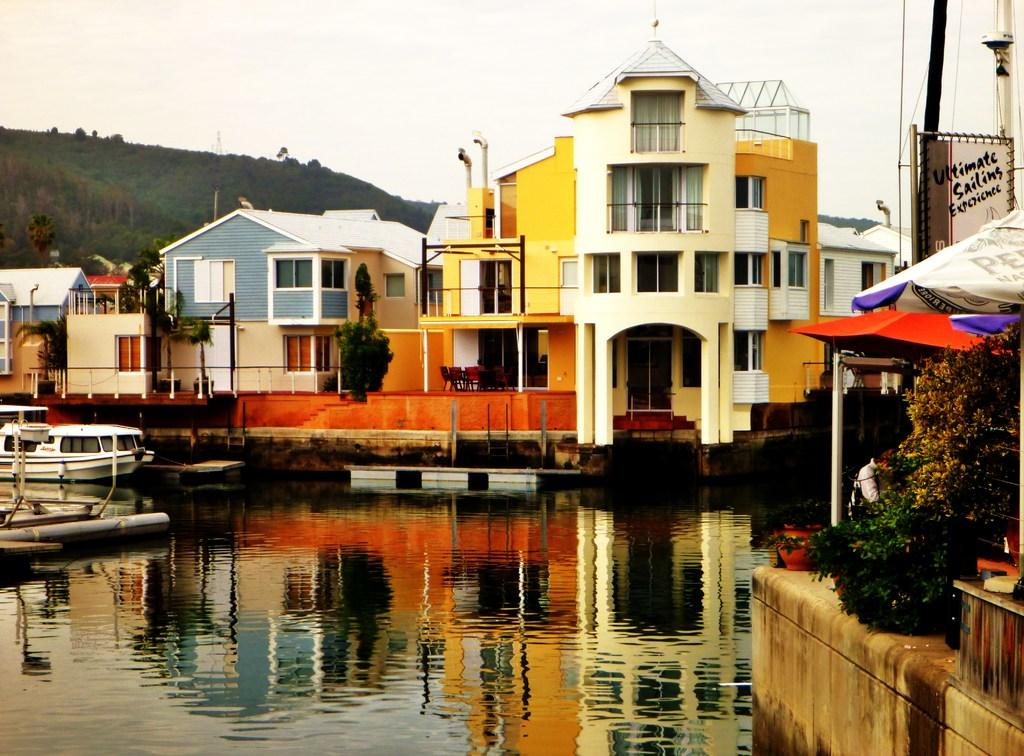What is on the water in the image? There are boats on the water in the image. What type of structures can be seen in the image? There are buildings visible in the image. What type of vegetation is present in the image? Trees are present in the image. Can you describe the person in the image? There is a person in the image. What type of furniture is visible in the image? Chairs are visible in the image. What other objects can be seen in the image? There are other objects in the image. What is visible in the background of the image? There is a mountain and the sky visible in the background of the image. What note is the manager giving to the father in the image? There is no mention of a manager, father, or note in the image. The image features boats on water, buildings, trees, a person, chairs, other objects, a mountain, and the sky in the background. 